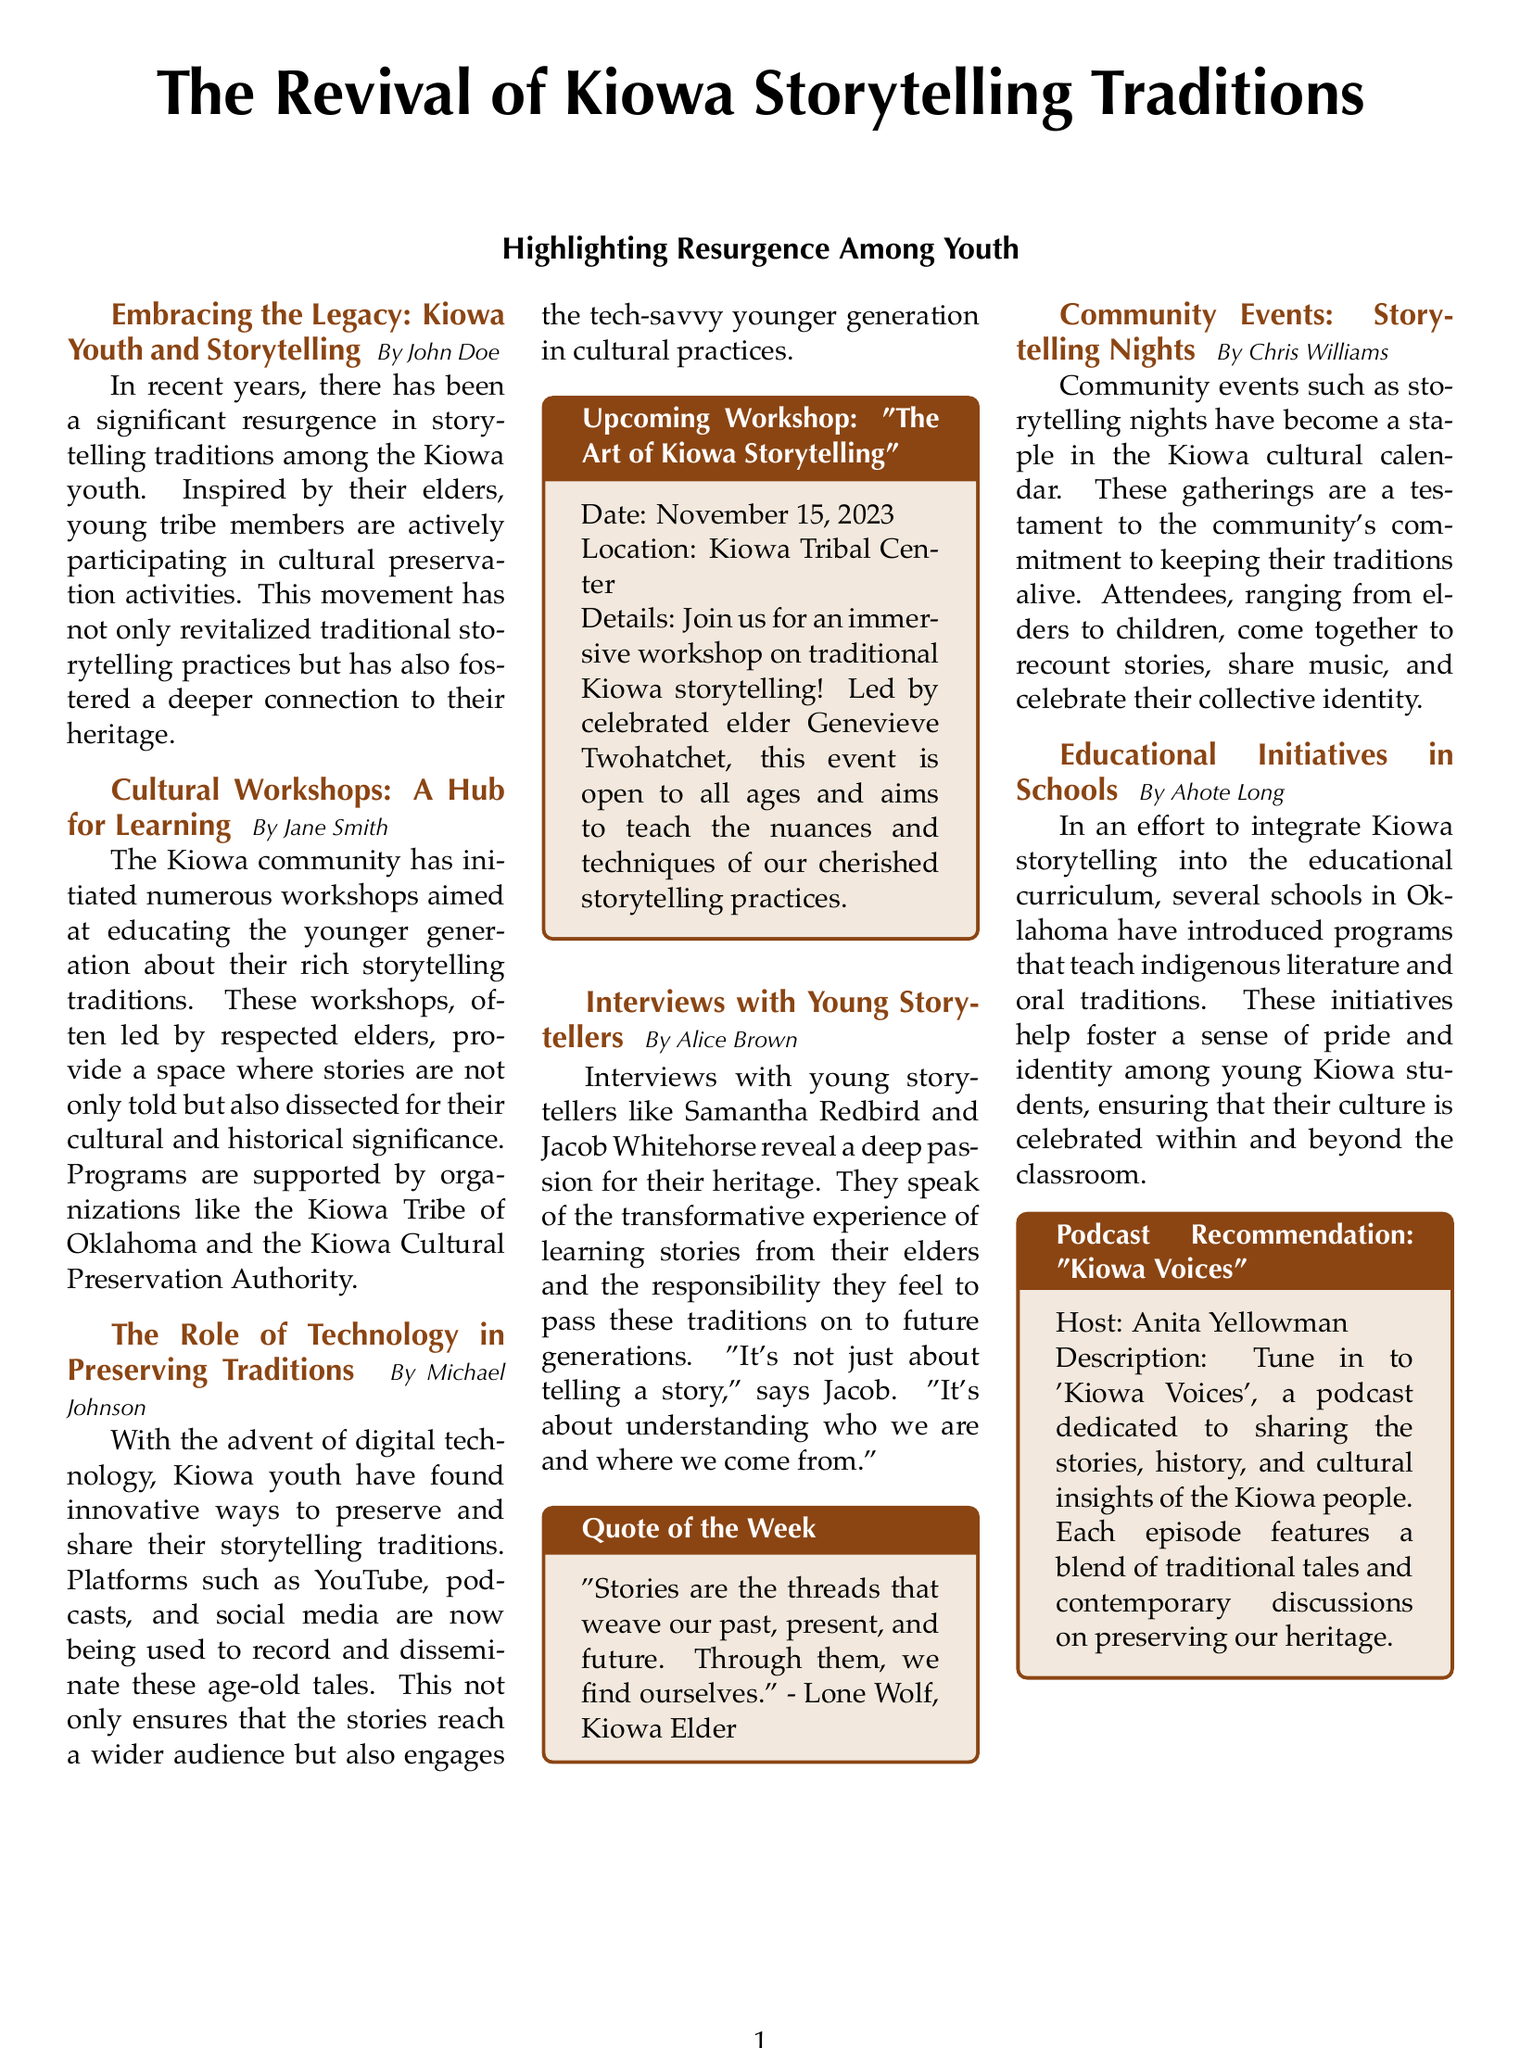What is the title of the article? The title of the article provides the main subject and focus of the document, which is about storytelling traditions.
Answer: The Revival of Kiowa Storytelling Traditions Who is the author of the article on cultural workshops? The author associated with cultural workshops adds credibility to that section, highlighting a distinct perspective on the workshops' importance.
Answer: Jane Smith When is the upcoming workshop on storytelling? The date of the upcoming workshop gives information about when community members can participate in learning and preserving storytelling practices.
Answer: November 15, 2023 Who leads the upcoming workshop? The individual leading the workshop signifies the value of mentorship and respect for elders in passing down traditions.
Answer: Genevieve Twohatchet What is the main theme discussed in interviews with young storytellers? The interviews focus on youth perspectives regarding their cultural heritage and storytelling experiences, showcasing their engagement with tradition.
Answer: Responsibility to pass traditions What is the podcast recommendation mentioned in the document? The podcast recommendation provides information on additional resources for learning about Kiowa culture and stories through modern media.
Answer: Kiowa Voices What initiative helps integrate Kiowa storytelling into schools? This initiative demonstrates the efforts to incorporate indigenous culture into educational settings, fostering identity among students.
Answer: Educational initiatives What is the color theme used in the document? Knowing the color theme can give insights into the document's visual representation and cultural significance regarding the Kiowa tribe.
Answer: Kiowa brown and Kiowa tan 